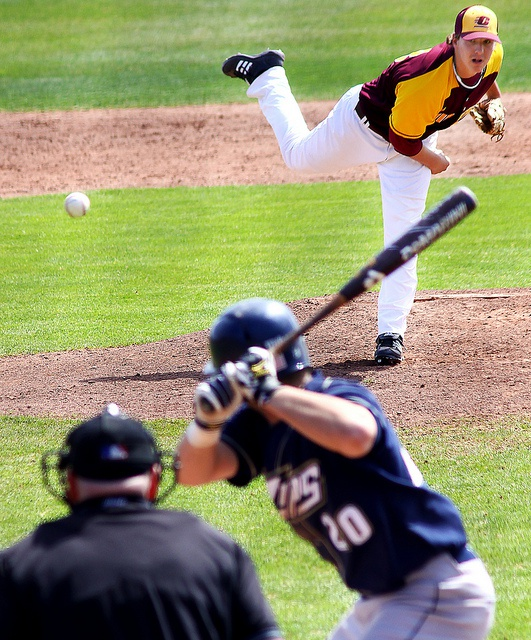Describe the objects in this image and their specific colors. I can see people in olive, black, white, gray, and brown tones, people in olive, black, and gray tones, people in olive, lavender, black, orange, and maroon tones, baseball bat in olive, black, gray, darkgray, and navy tones, and baseball glove in olive, white, black, maroon, and brown tones in this image. 